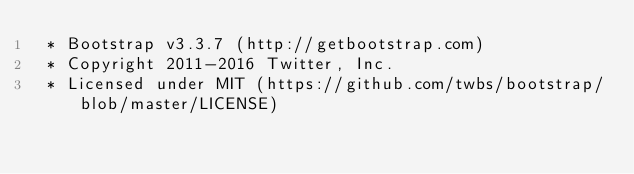<code> <loc_0><loc_0><loc_500><loc_500><_CSS_> * Bootstrap v3.3.7 (http://getbootstrap.com)
 * Copyright 2011-2016 Twitter, Inc.
 * Licensed under MIT (https://github.com/twbs/bootstrap/blob/master/LICENSE)</code> 